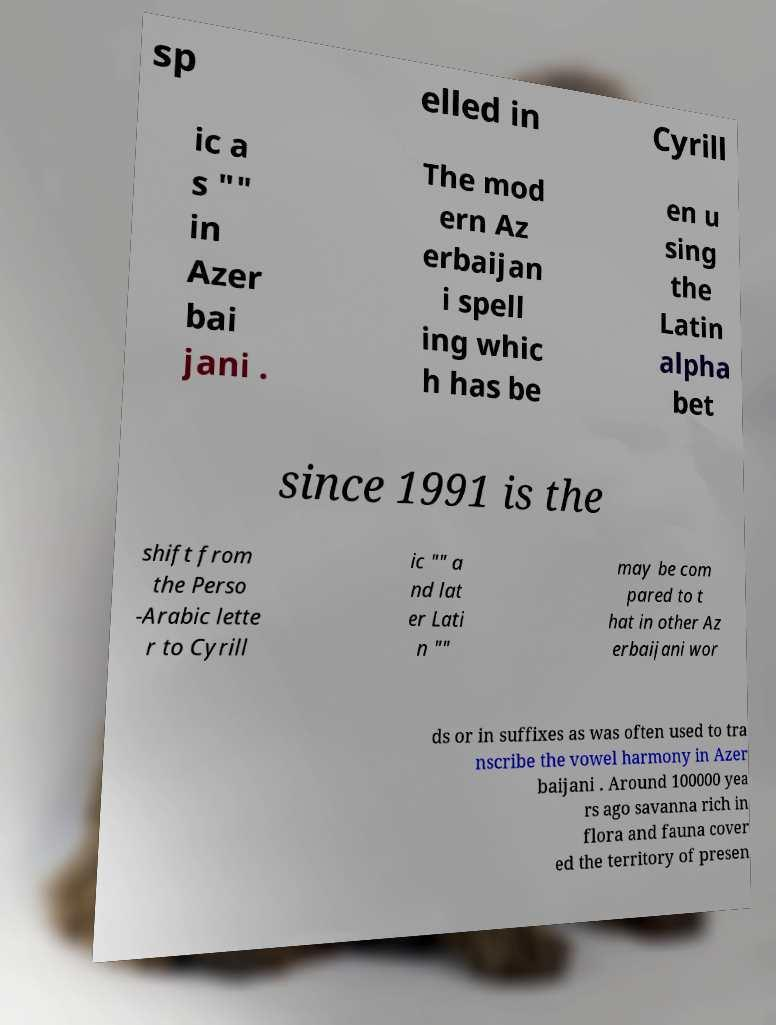There's text embedded in this image that I need extracted. Can you transcribe it verbatim? sp elled in Cyrill ic a s "" in Azer bai jani . The mod ern Az erbaijan i spell ing whic h has be en u sing the Latin alpha bet since 1991 is the shift from the Perso -Arabic lette r to Cyrill ic "" a nd lat er Lati n "" may be com pared to t hat in other Az erbaijani wor ds or in suffixes as was often used to tra nscribe the vowel harmony in Azer baijani . Around 100000 yea rs ago savanna rich in flora and fauna cover ed the territory of presen 